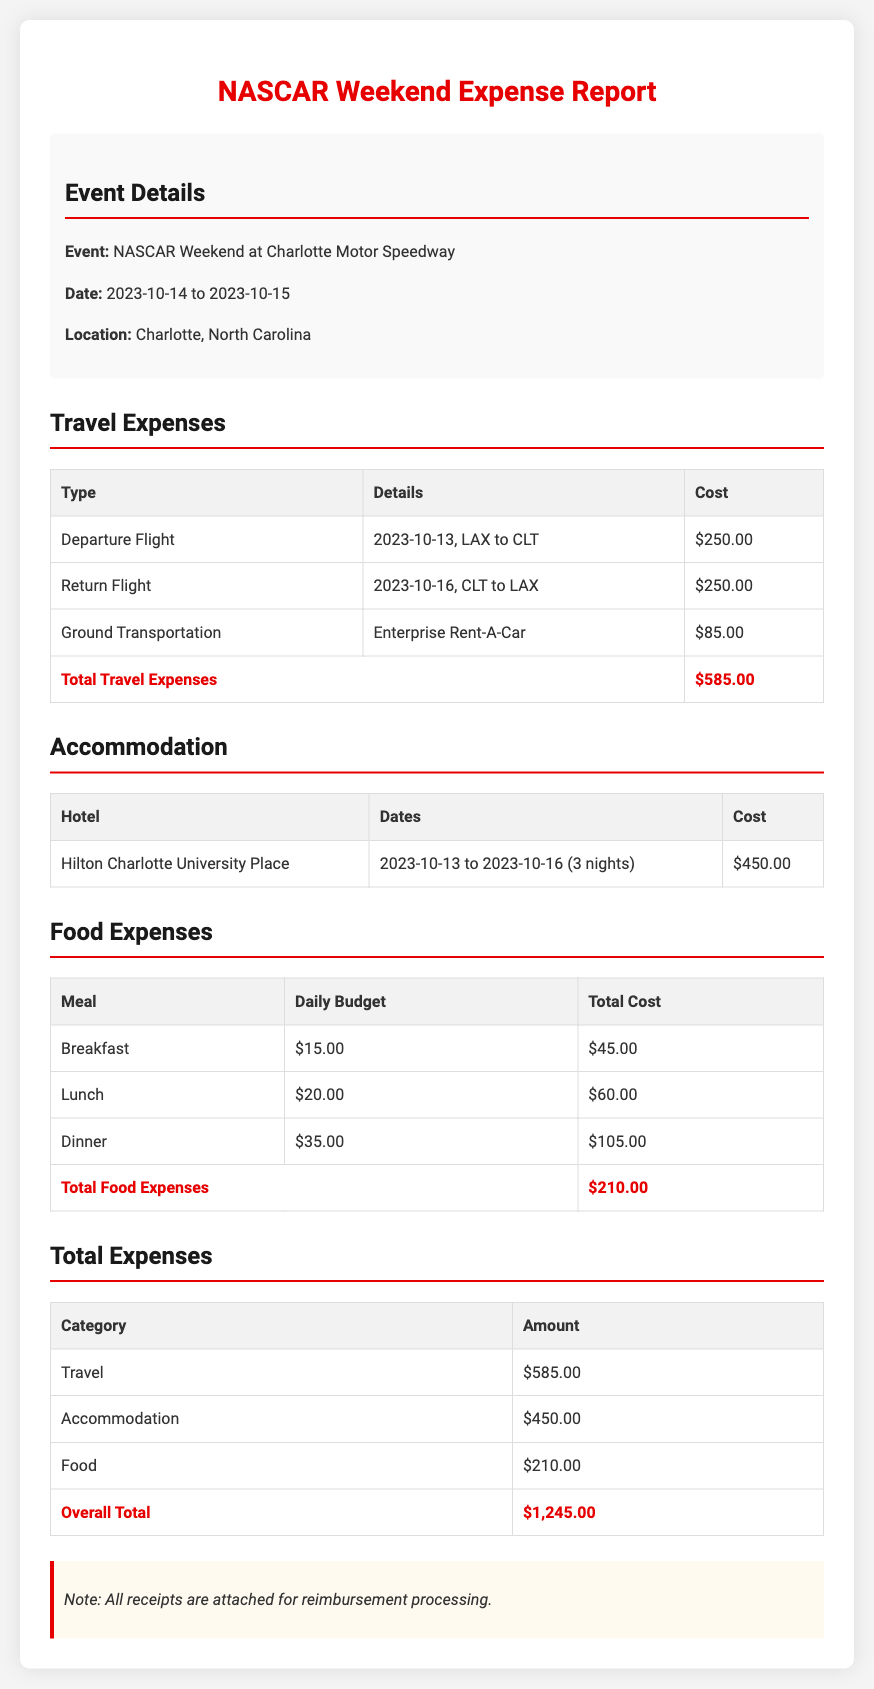what is the event location? The event took place at Charlotte Motor Speedway, as stated in the document.
Answer: Charlotte Motor Speedway what are the travel expenses? The travel expenses are detailed in the travel section including all flights and ground transportation.
Answer: $585.00 how many nights was accommodation booked? The document indicates that accommodation was booked for three nights at the hotel.
Answer: 3 nights what is the total cost for food expenses? The food expenses section lists the cost for breakfast, lunch, and dinner, which totals to the final amount.
Answer: $210.00 when did the event occur? The event took place from October 14 to October 15, 2023, as noted in the event details.
Answer: 2023-10-14 to 2023-10-15 what is the total accommodation cost? The document specifies the total cost for accommodation at the hotel over the three nights stay.
Answer: $450.00 what is the overall total of expenses? The total expenses section summarizes all costs incurred, providing a final figure.
Answer: $1,245.00 where was the return flight from? The document specifies the return flight details which indicate travel origin.
Answer: CLT to LAX how much was spent on breakfasts? The food expenses table provides the cost associated with breakfast over three days.
Answer: $45.00 